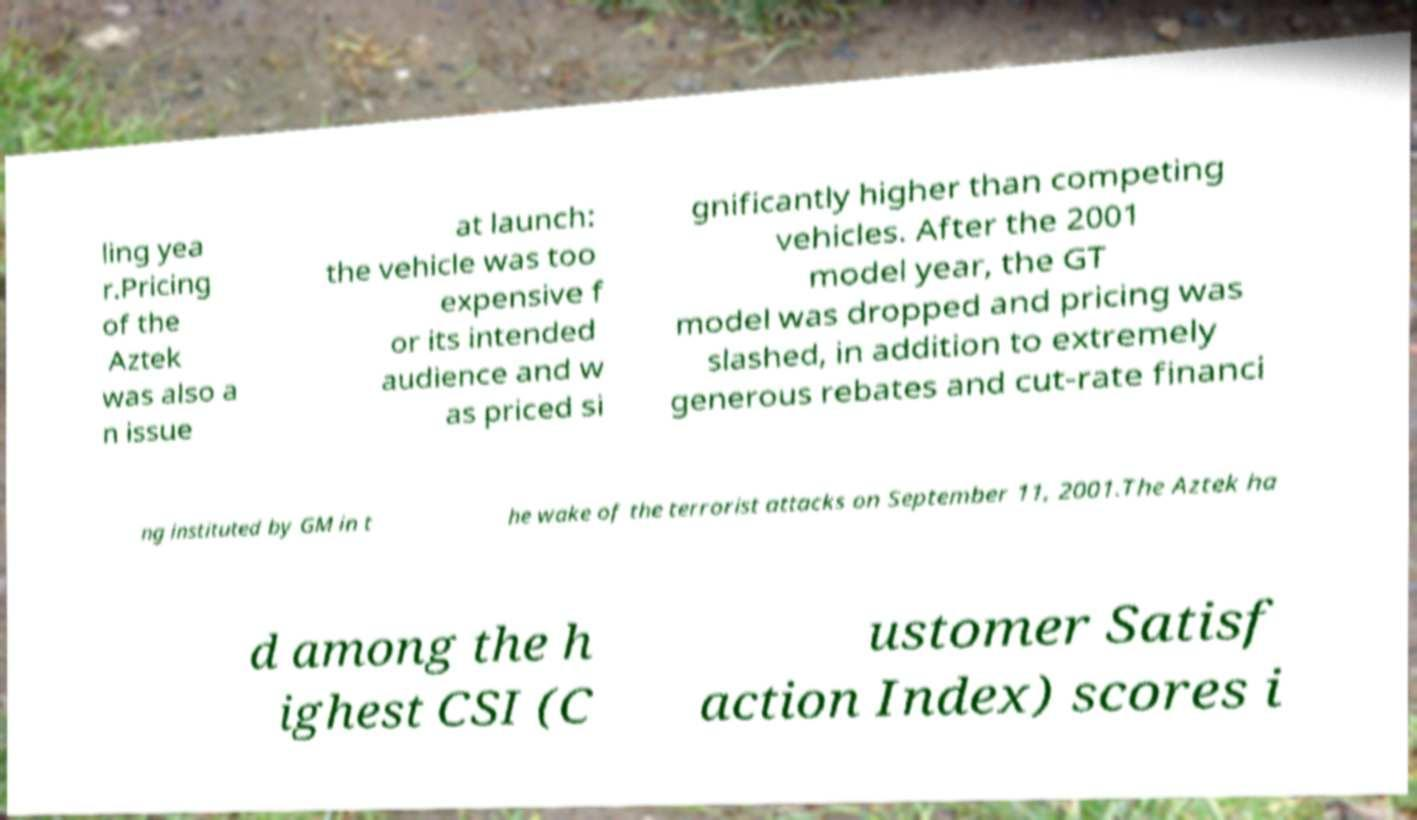Could you assist in decoding the text presented in this image and type it out clearly? ling yea r.Pricing of the Aztek was also a n issue at launch: the vehicle was too expensive f or its intended audience and w as priced si gnificantly higher than competing vehicles. After the 2001 model year, the GT model was dropped and pricing was slashed, in addition to extremely generous rebates and cut-rate financi ng instituted by GM in t he wake of the terrorist attacks on September 11, 2001.The Aztek ha d among the h ighest CSI (C ustomer Satisf action Index) scores i 